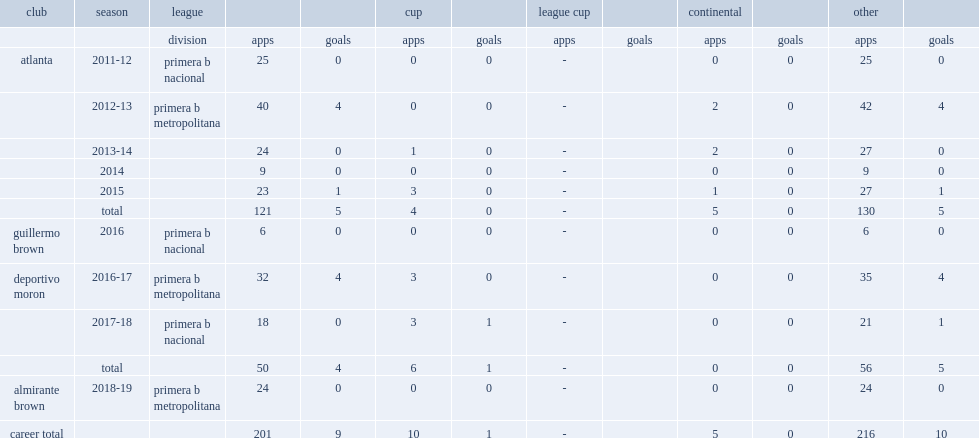In 2016, which league did guzman play for guillermo brown of? Primera b nacional. 